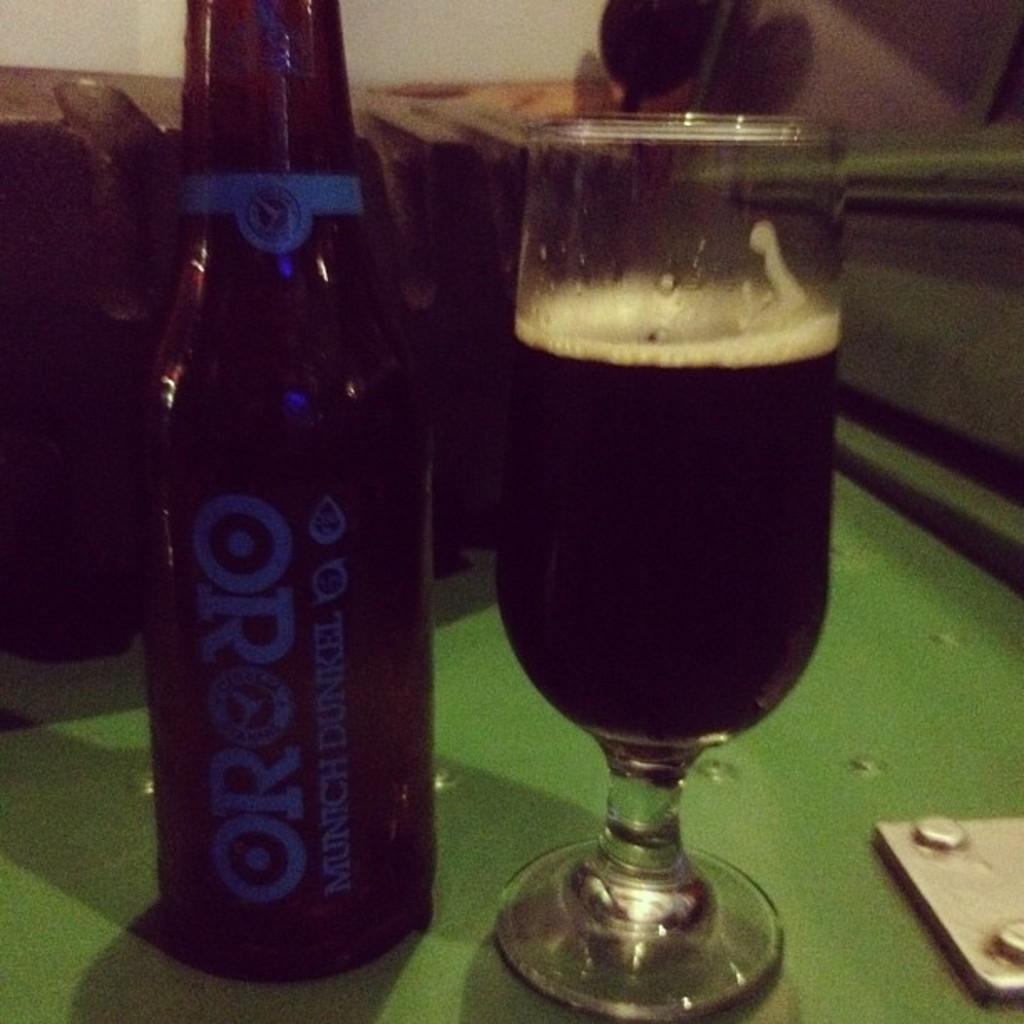Describe this image in one or two sentences. There is a bottle and a glass on a green surface. In the background it is blurred. On the bottle something is written. 